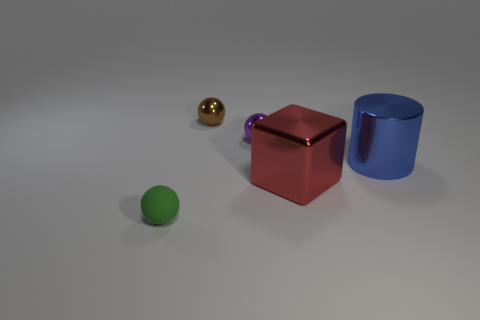Is the number of tiny purple things greater than the number of gray rubber objects?
Your answer should be very brief. Yes. What number of shiny things are behind the red cube and to the left of the large blue metallic cylinder?
Your response must be concise. 2. What number of things are on the right side of the small metallic thing that is in front of the brown ball?
Offer a terse response. 2. How many things are tiny purple metal things on the right side of the small green object or big things to the right of the red object?
Ensure brevity in your answer.  2. What material is the tiny green object that is the same shape as the small brown metal thing?
Ensure brevity in your answer.  Rubber. What number of things are either matte things left of the big red object or purple metal objects?
Give a very brief answer. 2. There is a tiny purple object that is the same material as the blue thing; what shape is it?
Offer a terse response. Sphere. What number of small metallic objects have the same shape as the rubber object?
Give a very brief answer. 2. What is the material of the big red cube?
Make the answer very short. Metal. There is a cylinder; is its color the same as the ball that is right of the brown metallic sphere?
Make the answer very short. No. 